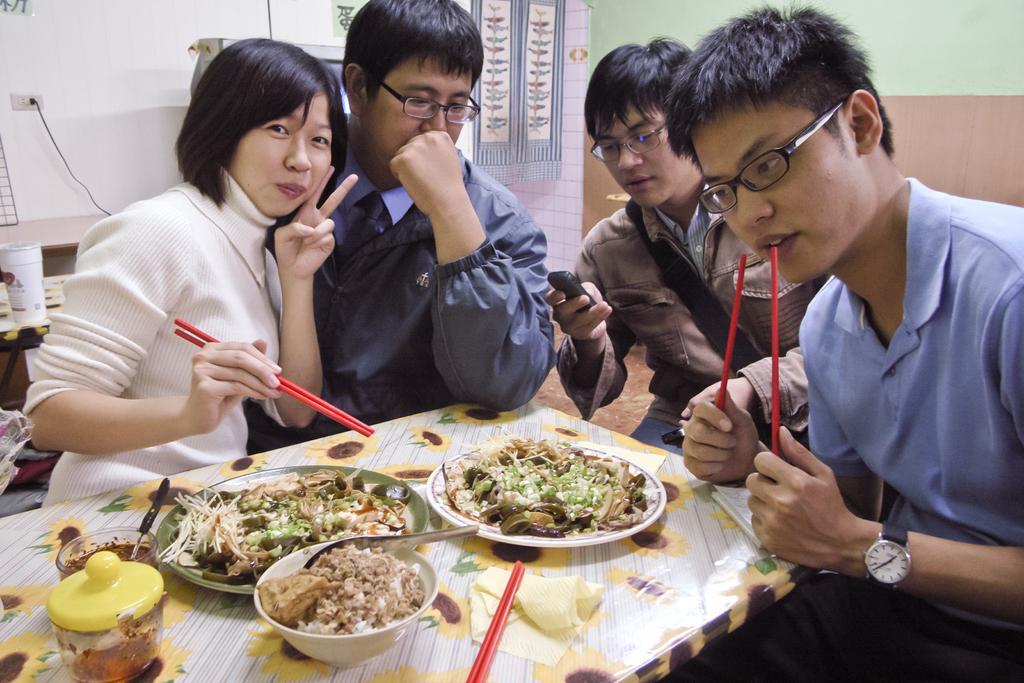In one or two sentences, can you explain what this image depicts? In the picture we can see four people are sitting on the chairs near the table on it, we can see some food items on the plates and they are holding a chopstick which are red in color and in the background we can see a wall with some switch and wire and some designs on the wall. 